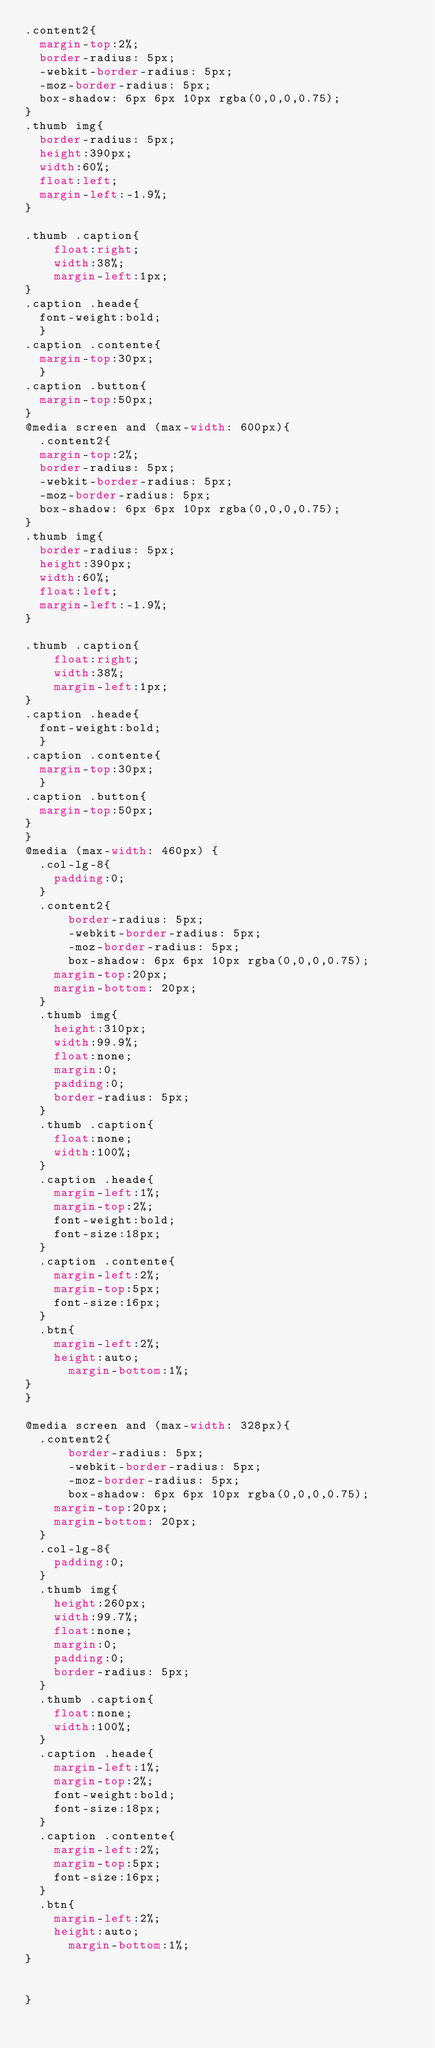<code> <loc_0><loc_0><loc_500><loc_500><_CSS_>.content2{
  margin-top:2%;
  border-radius: 5px;
  -webkit-border-radius: 5px;
  -moz-border-radius: 5px;
  box-shadow: 6px 6px 10px rgba(0,0,0,0.75);
}
.thumb img{
	border-radius: 5px;
  height:390px;
  width:60%;
  float:left;
  margin-left:-1.9%;
}

.thumb .caption{
    float:right;
    width:38%;
    margin-left:1px;
}
.caption .heade{
	font-weight:bold;
	}
.caption .contente{
	margin-top:30px;
	}
.caption .button{
	margin-top:50px;
}
@media screen and (max-width: 600px){
	.content2{
  margin-top:2%;
  border-radius: 5px;
  -webkit-border-radius: 5px;
  -moz-border-radius: 5px;
  box-shadow: 6px 6px 10px rgba(0,0,0,0.75);
}
.thumb img{
	border-radius: 5px;
  height:390px;
  width:60%;
  float:left;
  margin-left:-1.9%;
}

.thumb .caption{
    float:right;
    width:38%;
    margin-left:1px;
}
.caption .heade{
	font-weight:bold;
	}
.caption .contente{
	margin-top:30px;
	}
.caption .button{
	margin-top:50px;
}
}
@media (max-width: 460px) {
	.col-lg-8{
		padding:0;
	}
	.content2{
  		border-radius: 5px;
  		-webkit-border-radius: 5px;
  		-moz-border-radius: 5px;
  		box-shadow: 6px 6px 10px rgba(0,0,0,0.75);
		margin-top:20px;
		margin-bottom: 20px;
	}
	.thumb img{
		height:310px;
		width:99.9%;
		float:none;
		margin:0;
		padding:0;
		border-radius: 5px;
	}
	.thumb .caption{
		float:none;
		width:100%;
	}
	.caption .heade{
		margin-left:1%;
		margin-top:2%;
		font-weight:bold;
		font-size:18px;
	}
	.caption .contente{
		margin-left:2%;
		margin-top:5px;
		font-size:16px;
	}
	.btn{
		margin-left:2%;
		height:auto;
    	margin-bottom:1%;
}
}

@media screen and (max-width: 328px){
	.content2{
  		border-radius: 5px;
  		-webkit-border-radius: 5px;
  		-moz-border-radius: 5px;
  		box-shadow: 6px 6px 10px rgba(0,0,0,0.75);
		margin-top:20px;
		margin-bottom: 20px;
	}
	.col-lg-8{
		padding:0;
	}
	.thumb img{
		height:260px;
		width:99.7%;
		float:none;
		margin:0;
		padding:0;
		border-radius: 5px;
	}
	.thumb .caption{
		float:none;
		width:100%;
	}
	.caption .heade{
		margin-left:1%;
		margin-top:2%;
		font-weight:bold;
		font-size:18px;
	}
	.caption .contente{
		margin-left:2%;
		margin-top:5px;
		font-size:16px;
	}
	.btn{
		margin-left:2%;
		height:auto;
    	margin-bottom:1%;
}
	

}
</code> 